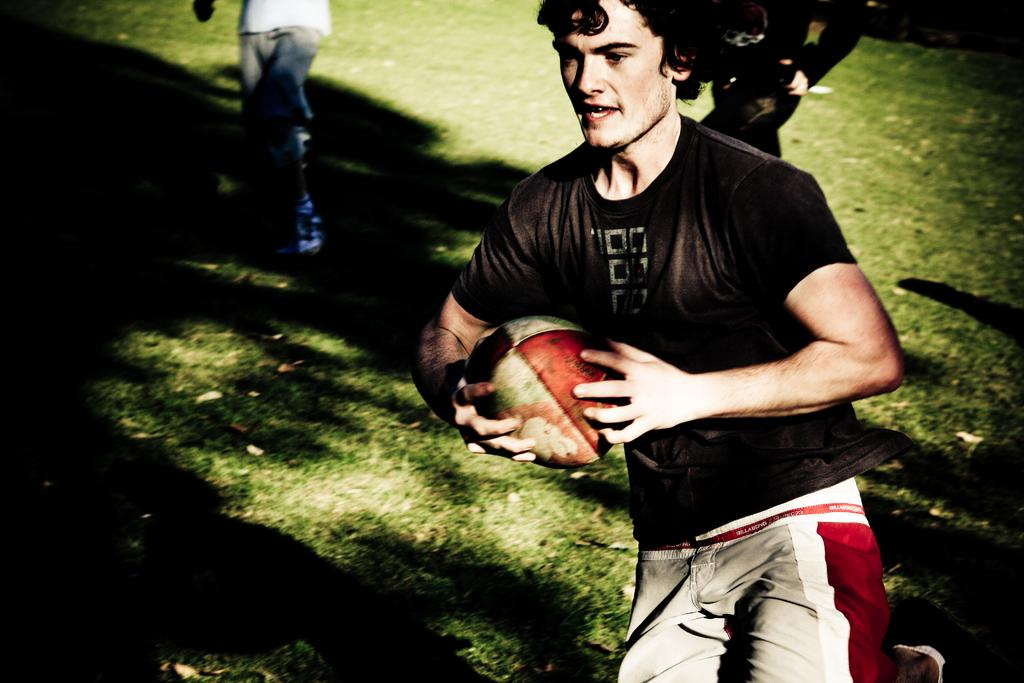What is the person in the image holding? The person is holding a rugby ball in the image. What is the person doing with the rugby ball? The person is running on the ground while holding the rugby ball. Are there any other people in the image? Yes, there are two other persons behind the running person. What type of turkey can be seen in the image? There is no turkey present in the image. Is the person running in a rainstorm in the image? The image does not show any indication of a rainstorm, so it cannot be determined from the image. 